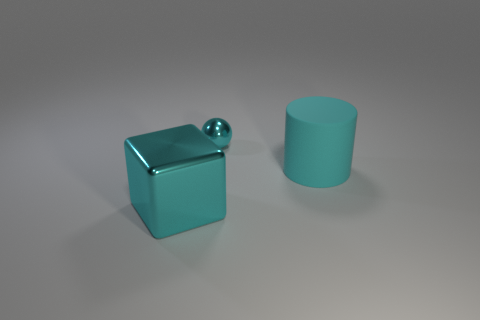What color is the small metal thing?
Your answer should be very brief. Cyan. There is a tiny metallic thing that is the same color as the metallic block; what shape is it?
Keep it short and to the point. Sphere. Are any tiny purple rubber objects visible?
Offer a very short reply. No. What is the size of the cyan object that is the same material as the large cyan block?
Offer a terse response. Small. The big cyan thing behind the large cyan object that is to the left of the thing that is to the right of the tiny cyan ball is what shape?
Your response must be concise. Cylinder. Are there an equal number of big cylinders that are behind the large rubber thing and cyan objects?
Give a very brief answer. No. There is a matte cylinder that is the same color as the tiny object; what is its size?
Your response must be concise. Large. Is the shape of the big matte object the same as the tiny cyan shiny object?
Provide a succinct answer. No. How many objects are either cyan metal objects behind the large shiny block or small rubber blocks?
Give a very brief answer. 1. Is the number of matte objects behind the cyan matte thing the same as the number of big matte things on the left side of the big metal object?
Your answer should be very brief. Yes. 